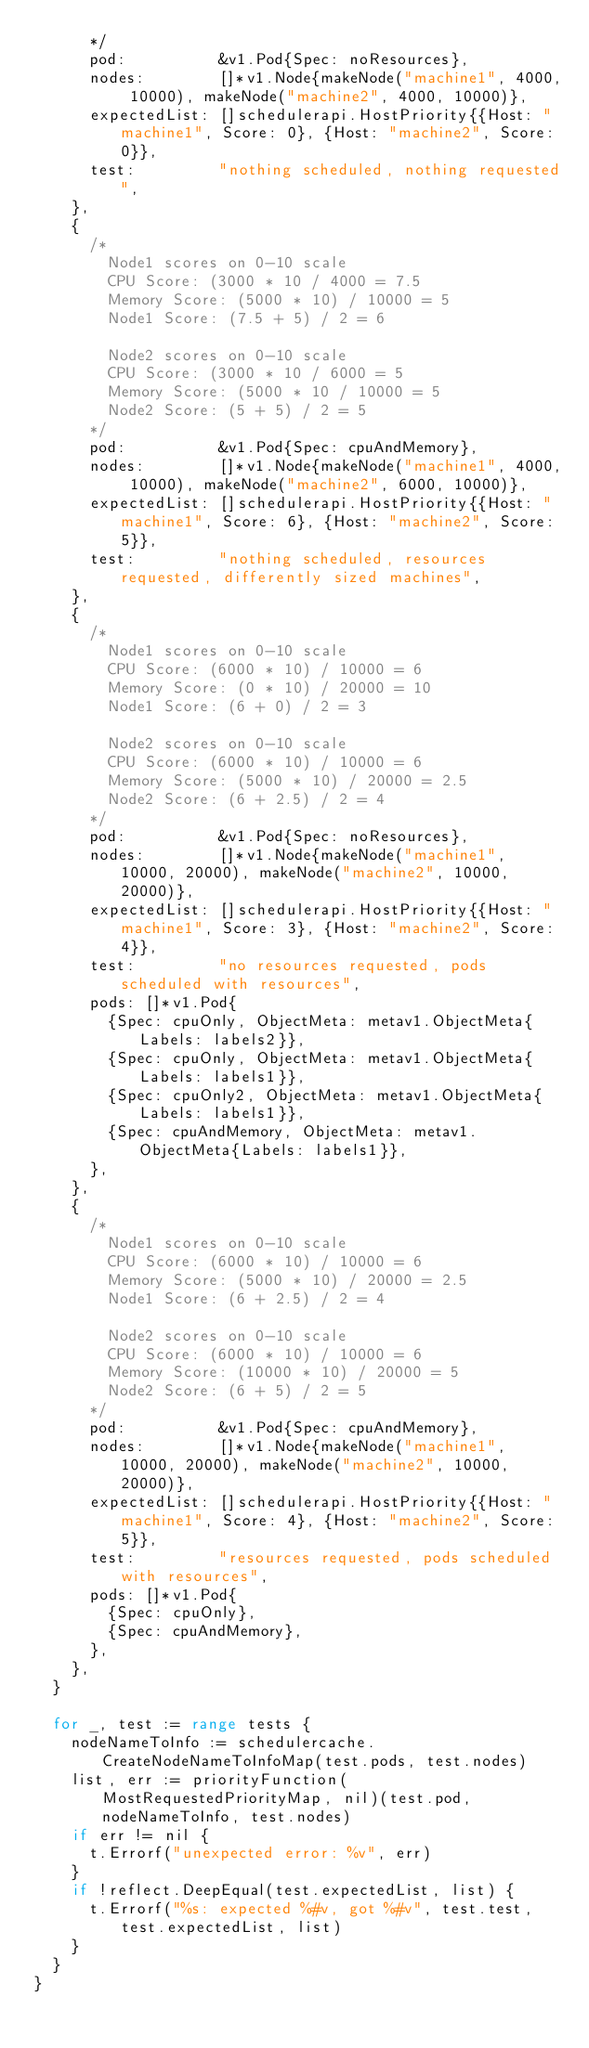Convert code to text. <code><loc_0><loc_0><loc_500><loc_500><_Go_>			*/
			pod:          &v1.Pod{Spec: noResources},
			nodes:        []*v1.Node{makeNode("machine1", 4000, 10000), makeNode("machine2", 4000, 10000)},
			expectedList: []schedulerapi.HostPriority{{Host: "machine1", Score: 0}, {Host: "machine2", Score: 0}},
			test:         "nothing scheduled, nothing requested",
		},
		{
			/*
				Node1 scores on 0-10 scale
				CPU Score: (3000 * 10 / 4000 = 7.5
				Memory Score: (5000 * 10) / 10000 = 5
				Node1 Score: (7.5 + 5) / 2 = 6

				Node2 scores on 0-10 scale
				CPU Score: (3000 * 10 / 6000 = 5
				Memory Score: (5000 * 10 / 10000 = 5
				Node2 Score: (5 + 5) / 2 = 5
			*/
			pod:          &v1.Pod{Spec: cpuAndMemory},
			nodes:        []*v1.Node{makeNode("machine1", 4000, 10000), makeNode("machine2", 6000, 10000)},
			expectedList: []schedulerapi.HostPriority{{Host: "machine1", Score: 6}, {Host: "machine2", Score: 5}},
			test:         "nothing scheduled, resources requested, differently sized machines",
		},
		{
			/*
				Node1 scores on 0-10 scale
				CPU Score: (6000 * 10) / 10000 = 6
				Memory Score: (0 * 10) / 20000 = 10
				Node1 Score: (6 + 0) / 2 = 3

				Node2 scores on 0-10 scale
				CPU Score: (6000 * 10) / 10000 = 6
				Memory Score: (5000 * 10) / 20000 = 2.5
				Node2 Score: (6 + 2.5) / 2 = 4
			*/
			pod:          &v1.Pod{Spec: noResources},
			nodes:        []*v1.Node{makeNode("machine1", 10000, 20000), makeNode("machine2", 10000, 20000)},
			expectedList: []schedulerapi.HostPriority{{Host: "machine1", Score: 3}, {Host: "machine2", Score: 4}},
			test:         "no resources requested, pods scheduled with resources",
			pods: []*v1.Pod{
				{Spec: cpuOnly, ObjectMeta: metav1.ObjectMeta{Labels: labels2}},
				{Spec: cpuOnly, ObjectMeta: metav1.ObjectMeta{Labels: labels1}},
				{Spec: cpuOnly2, ObjectMeta: metav1.ObjectMeta{Labels: labels1}},
				{Spec: cpuAndMemory, ObjectMeta: metav1.ObjectMeta{Labels: labels1}},
			},
		},
		{
			/*
				Node1 scores on 0-10 scale
				CPU Score: (6000 * 10) / 10000 = 6
				Memory Score: (5000 * 10) / 20000 = 2.5
				Node1 Score: (6 + 2.5) / 2 = 4

				Node2 scores on 0-10 scale
				CPU Score: (6000 * 10) / 10000 = 6
				Memory Score: (10000 * 10) / 20000 = 5
				Node2 Score: (6 + 5) / 2 = 5
			*/
			pod:          &v1.Pod{Spec: cpuAndMemory},
			nodes:        []*v1.Node{makeNode("machine1", 10000, 20000), makeNode("machine2", 10000, 20000)},
			expectedList: []schedulerapi.HostPriority{{Host: "machine1", Score: 4}, {Host: "machine2", Score: 5}},
			test:         "resources requested, pods scheduled with resources",
			pods: []*v1.Pod{
				{Spec: cpuOnly},
				{Spec: cpuAndMemory},
			},
		},
	}

	for _, test := range tests {
		nodeNameToInfo := schedulercache.CreateNodeNameToInfoMap(test.pods, test.nodes)
		list, err := priorityFunction(MostRequestedPriorityMap, nil)(test.pod, nodeNameToInfo, test.nodes)
		if err != nil {
			t.Errorf("unexpected error: %v", err)
		}
		if !reflect.DeepEqual(test.expectedList, list) {
			t.Errorf("%s: expected %#v, got %#v", test.test, test.expectedList, list)
		}
	}
}
</code> 